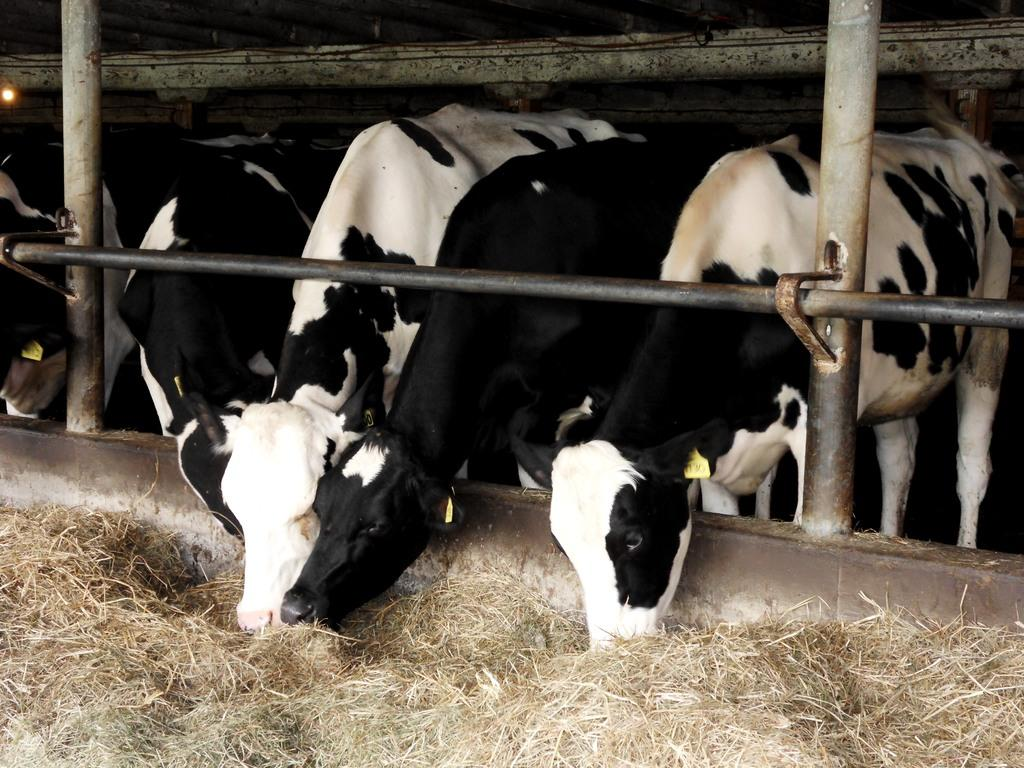What animals can be seen in the image? There are cattle in the image. What are the cattle doing in the image? The cattle are grazing in the image. Where are the cattle located in the image? The cattle are in a field in the image. What type of hook can be seen hanging from the cattle in the image? There are no hooks present in the image; the cattle are simply grazing in a field. 